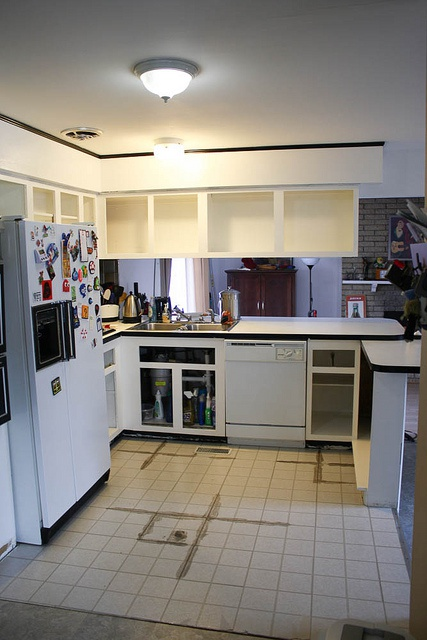Describe the objects in this image and their specific colors. I can see refrigerator in gray, darkgray, and black tones, sink in gray, darkgray, black, and tan tones, cup in gray, black, blue, and navy tones, book in gray and black tones, and bottle in gray, black, darkgray, and darkgreen tones in this image. 